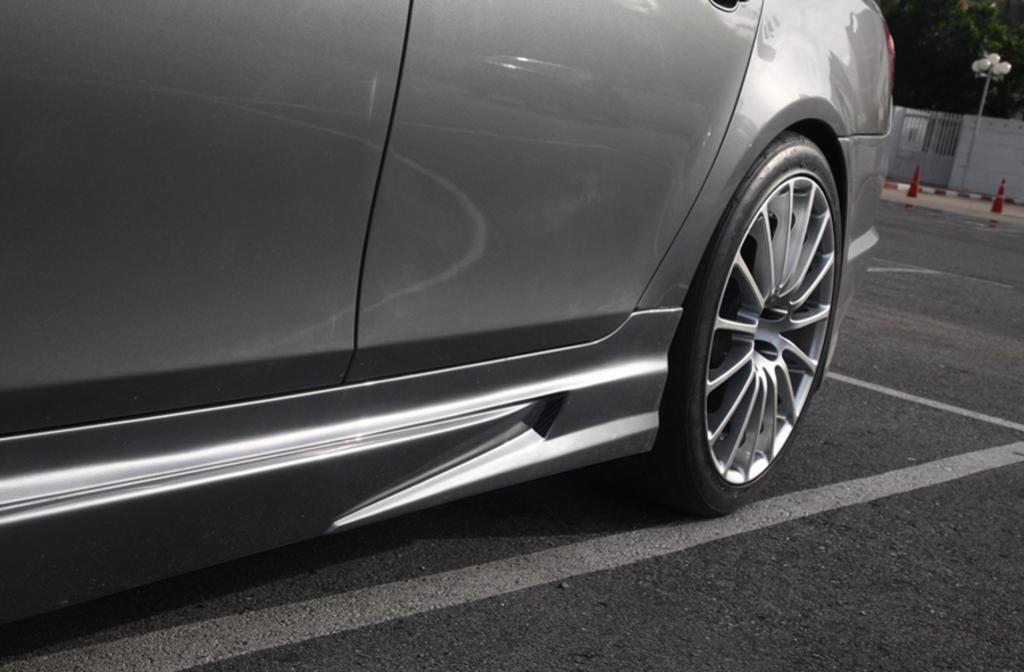Please provide a concise description of this image. This image is taken outdoors. At the bottom of the image there is a road. At the top right of the image there are few trees. There is a wall and there is a gate. There is a street light and there are two safety cones on the road. In the middle of the image a car is parked on the road. 